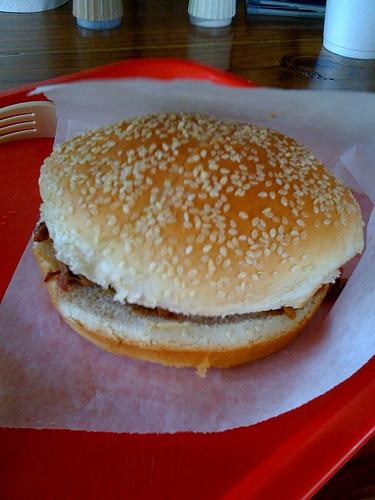What is on top of the bun? Please explain your reasoning. seeds. These are sesame seeds and these are found on many different styles of buns. 